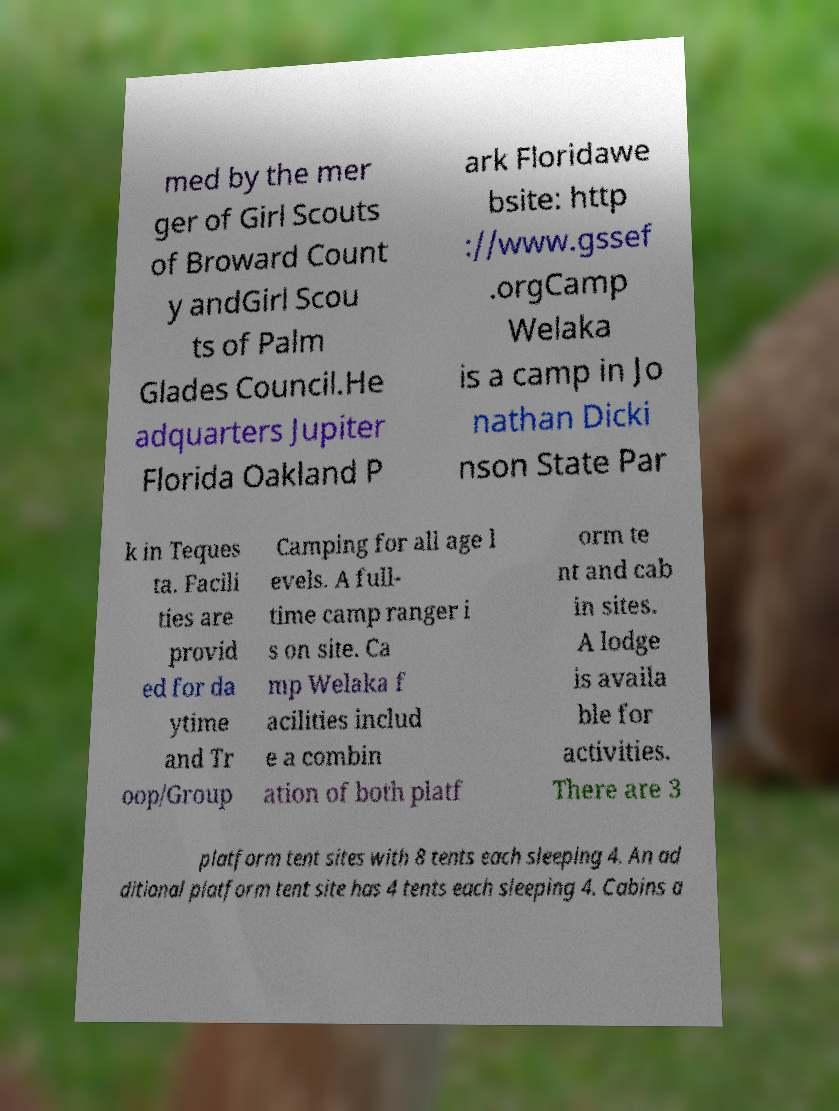Please identify and transcribe the text found in this image. med by the mer ger of Girl Scouts of Broward Count y andGirl Scou ts of Palm Glades Council.He adquarters Jupiter Florida Oakland P ark Floridawe bsite: http ://www.gssef .orgCamp Welaka is a camp in Jo nathan Dicki nson State Par k in Teques ta. Facili ties are provid ed for da ytime and Tr oop/Group Camping for all age l evels. A full- time camp ranger i s on site. Ca mp Welaka f acilities includ e a combin ation of both platf orm te nt and cab in sites. A lodge is availa ble for activities. There are 3 platform tent sites with 8 tents each sleeping 4. An ad ditional platform tent site has 4 tents each sleeping 4. Cabins a 